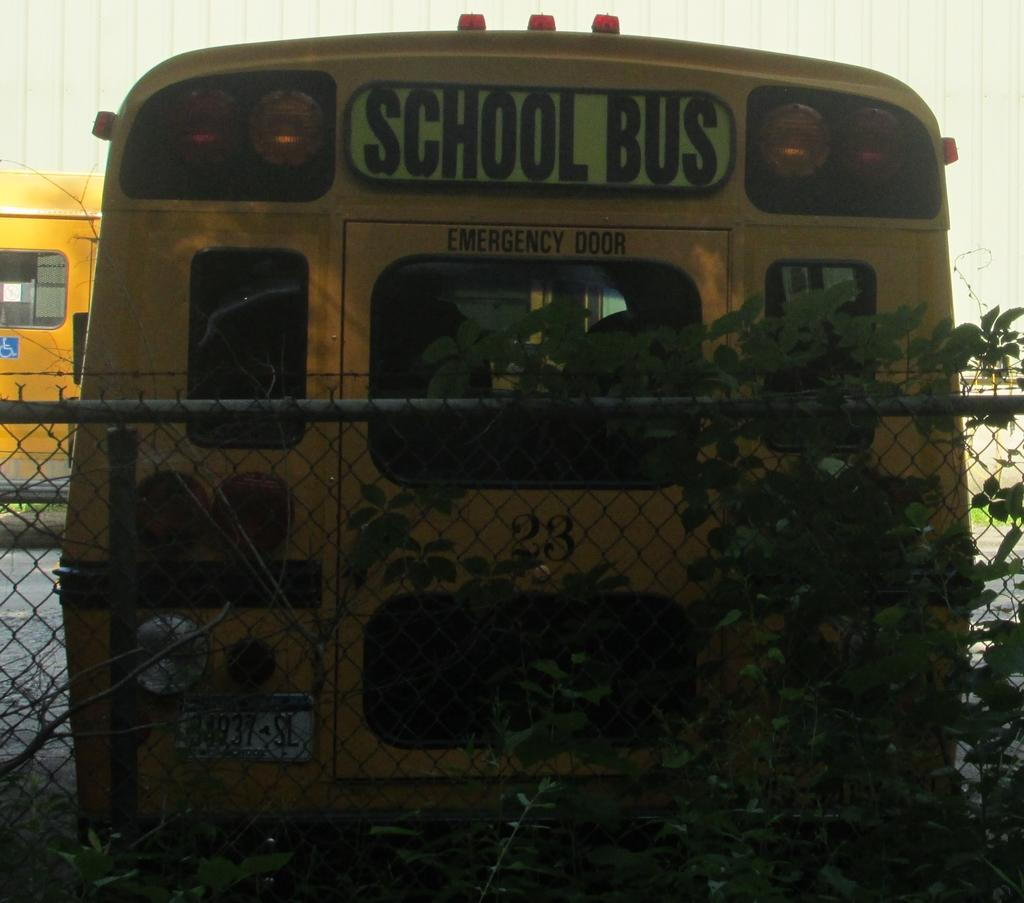Provide a one-sentence caption for the provided image. The school bus was parked next to a wired fence. 